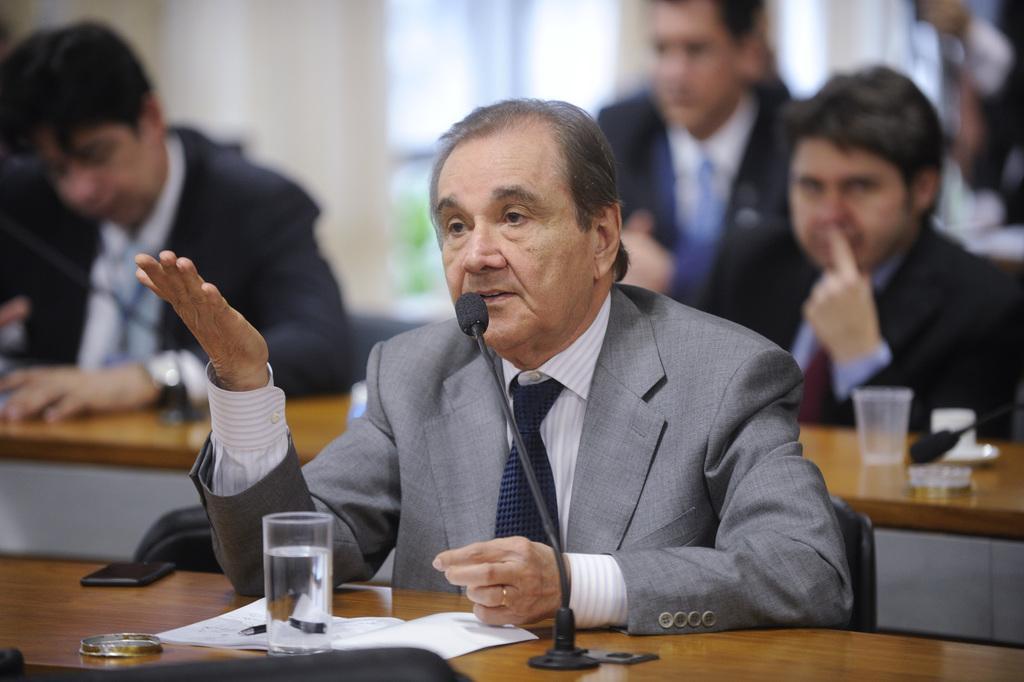Describe this image in one or two sentences. In this image there is a man sitting in the chair. In front of him there is a table on which there is a mic,glass and a paper on which there is a pen. In the background there are few other people who are sitting in front of the tables. In the background there is a building with the windows. 